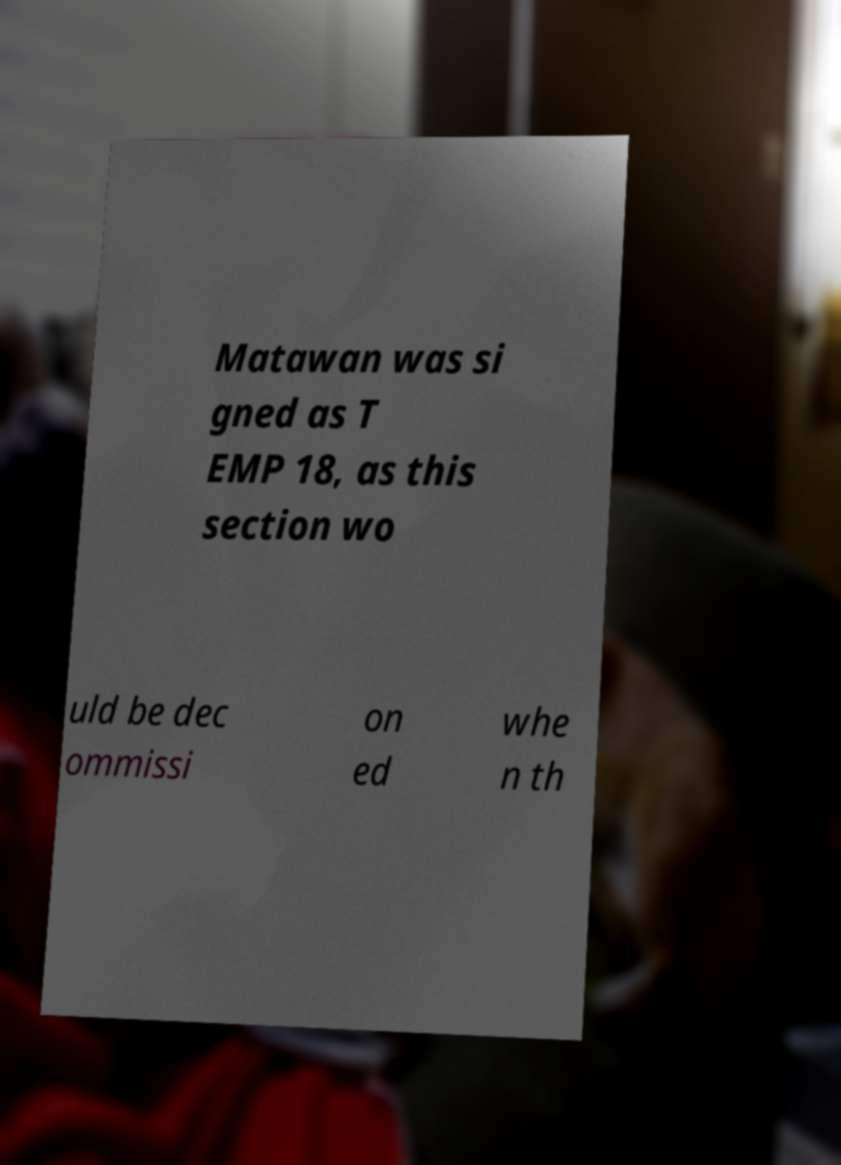Could you extract and type out the text from this image? Matawan was si gned as T EMP 18, as this section wo uld be dec ommissi on ed whe n th 